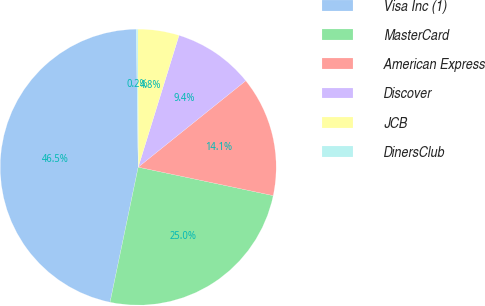Convert chart. <chart><loc_0><loc_0><loc_500><loc_500><pie_chart><fcel>Visa Inc (1)<fcel>MasterCard<fcel>American Express<fcel>Discover<fcel>JCB<fcel>DinersClub<nl><fcel>46.51%<fcel>24.96%<fcel>14.08%<fcel>9.45%<fcel>4.82%<fcel>0.18%<nl></chart> 